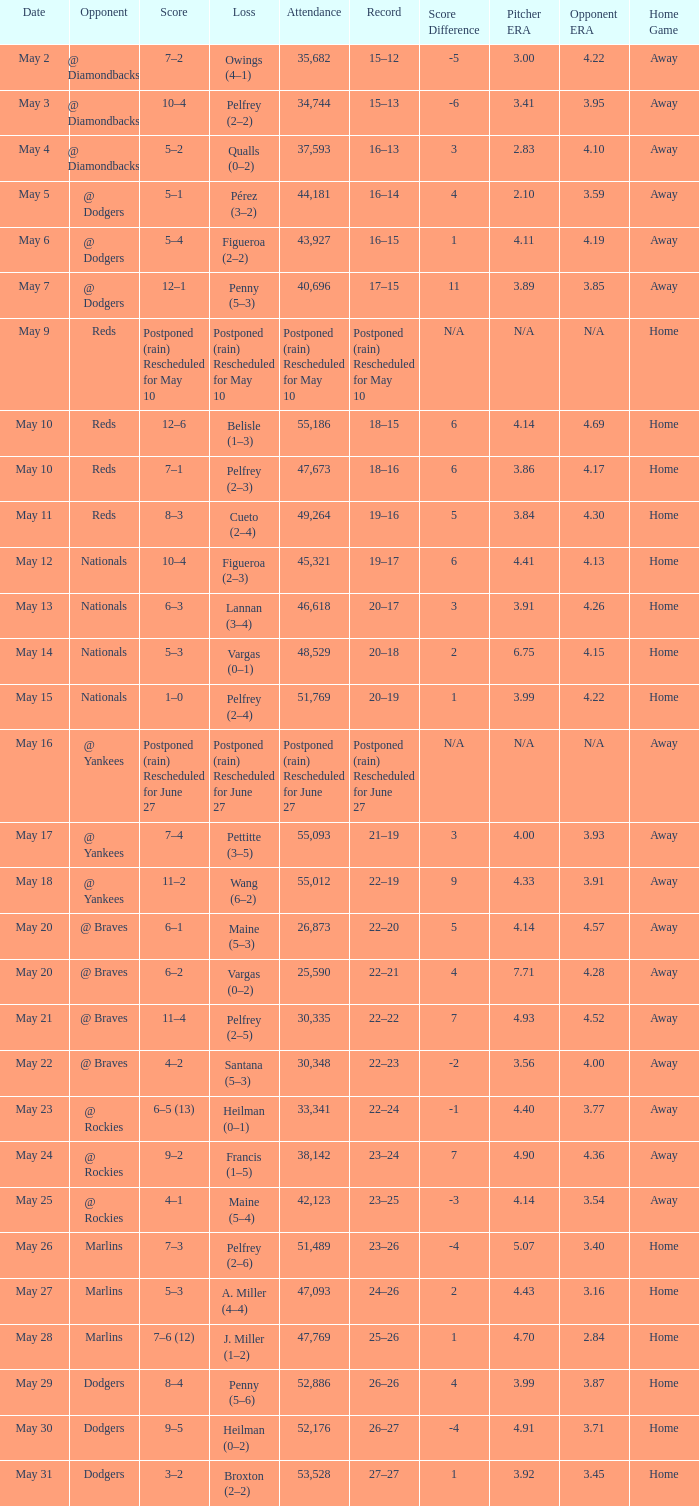Loss of postponed (rain) rescheduled for may 10 had what record? Postponed (rain) Rescheduled for May 10. 